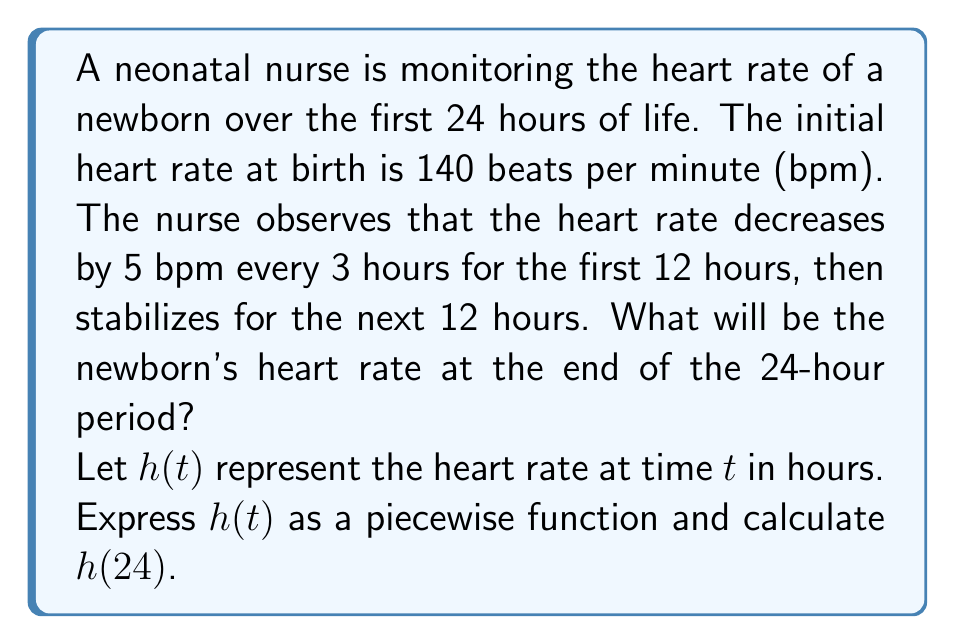Give your solution to this math problem. Let's approach this step-by-step:

1) First, we need to define our piecewise function $h(t)$:

   $$h(t) = \begin{cases}
   140 - \frac{5}{3}t & \text{for } 0 \leq t < 12 \\
   h(12) & \text{for } 12 \leq t \leq 24
   \end{cases}$$

2) To find $h(12)$, we use the first piece of the function:
   
   $$h(12) = 140 - \frac{5}{3}(12) = 140 - 20 = 120$$

3) So, our complete piecewise function is:

   $$h(t) = \begin{cases}
   140 - \frac{5}{3}t & \text{for } 0 \leq t < 12 \\
   120 & \text{for } 12 \leq t \leq 24
   \end{cases}$$

4) To find the heart rate at 24 hours, we simply need to evaluate $h(24)$:

   Since 24 is in the second interval (12 ≤ t ≤ 24), we use the second piece of the function.

   $$h(24) = 120$$

Therefore, the newborn's heart rate at the end of the 24-hour period will be 120 bpm.
Answer: 120 bpm 